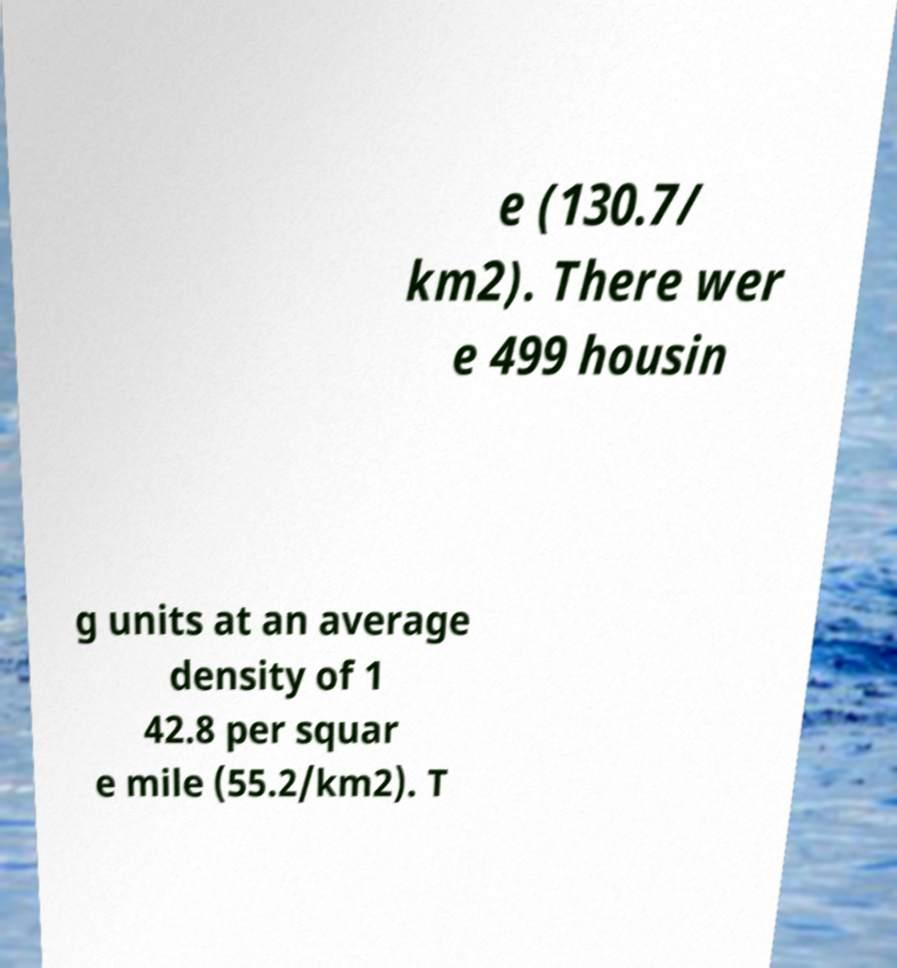Can you read and provide the text displayed in the image?This photo seems to have some interesting text. Can you extract and type it out for me? e (130.7/ km2). There wer e 499 housin g units at an average density of 1 42.8 per squar e mile (55.2/km2). T 